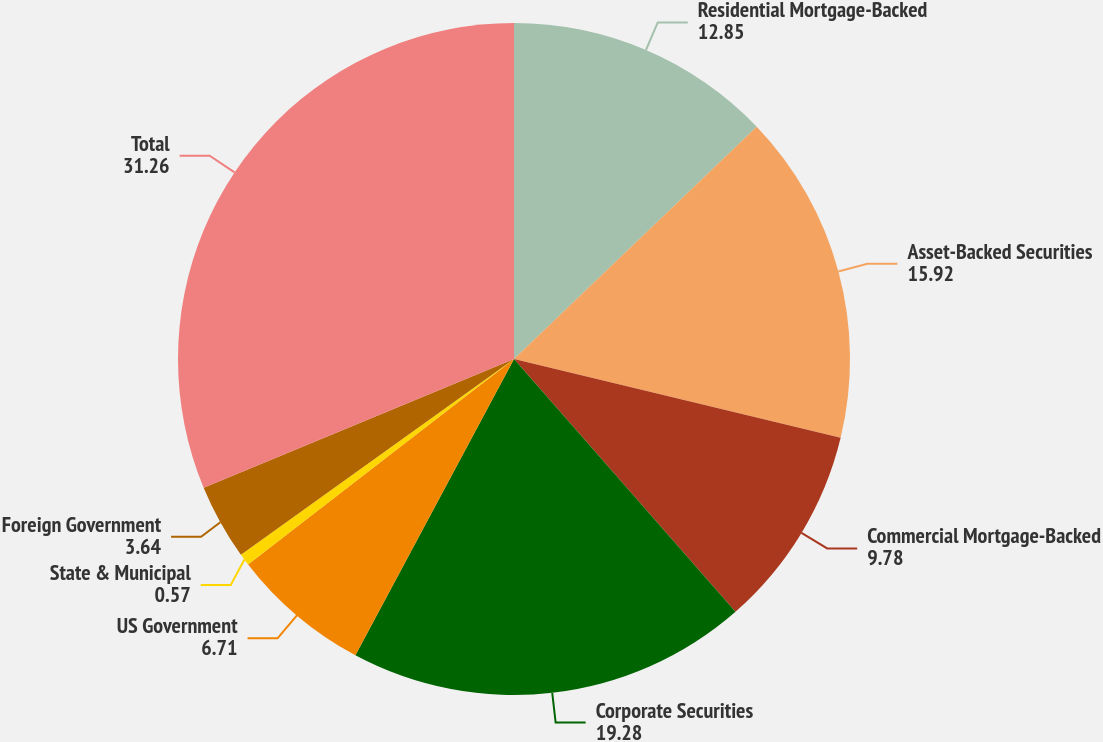Convert chart to OTSL. <chart><loc_0><loc_0><loc_500><loc_500><pie_chart><fcel>Residential Mortgage-Backed<fcel>Asset-Backed Securities<fcel>Commercial Mortgage-Backed<fcel>Corporate Securities<fcel>US Government<fcel>State & Municipal<fcel>Foreign Government<fcel>Total<nl><fcel>12.85%<fcel>15.92%<fcel>9.78%<fcel>19.28%<fcel>6.71%<fcel>0.57%<fcel>3.64%<fcel>31.26%<nl></chart> 